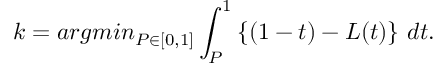Convert formula to latex. <formula><loc_0><loc_0><loc_500><loc_500>k = \arg \min _ { P \in [ 0 , 1 ] } \int _ { P } ^ { 1 } \left \{ ( 1 - t ) - L ( t ) \right \} \, d t .</formula> 